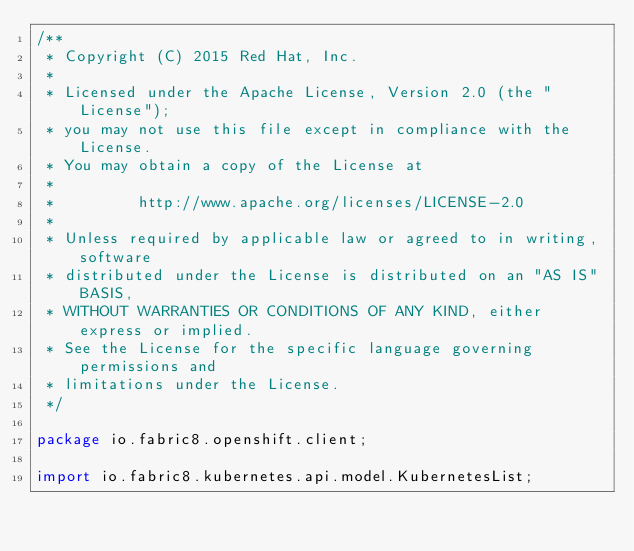<code> <loc_0><loc_0><loc_500><loc_500><_Java_>/**
 * Copyright (C) 2015 Red Hat, Inc.
 *
 * Licensed under the Apache License, Version 2.0 (the "License");
 * you may not use this file except in compliance with the License.
 * You may obtain a copy of the License at
 *
 *         http://www.apache.org/licenses/LICENSE-2.0
 *
 * Unless required by applicable law or agreed to in writing, software
 * distributed under the License is distributed on an "AS IS" BASIS,
 * WITHOUT WARRANTIES OR CONDITIONS OF ANY KIND, either express or implied.
 * See the License for the specific language governing permissions and
 * limitations under the License.
 */

package io.fabric8.openshift.client;

import io.fabric8.kubernetes.api.model.KubernetesList;</code> 